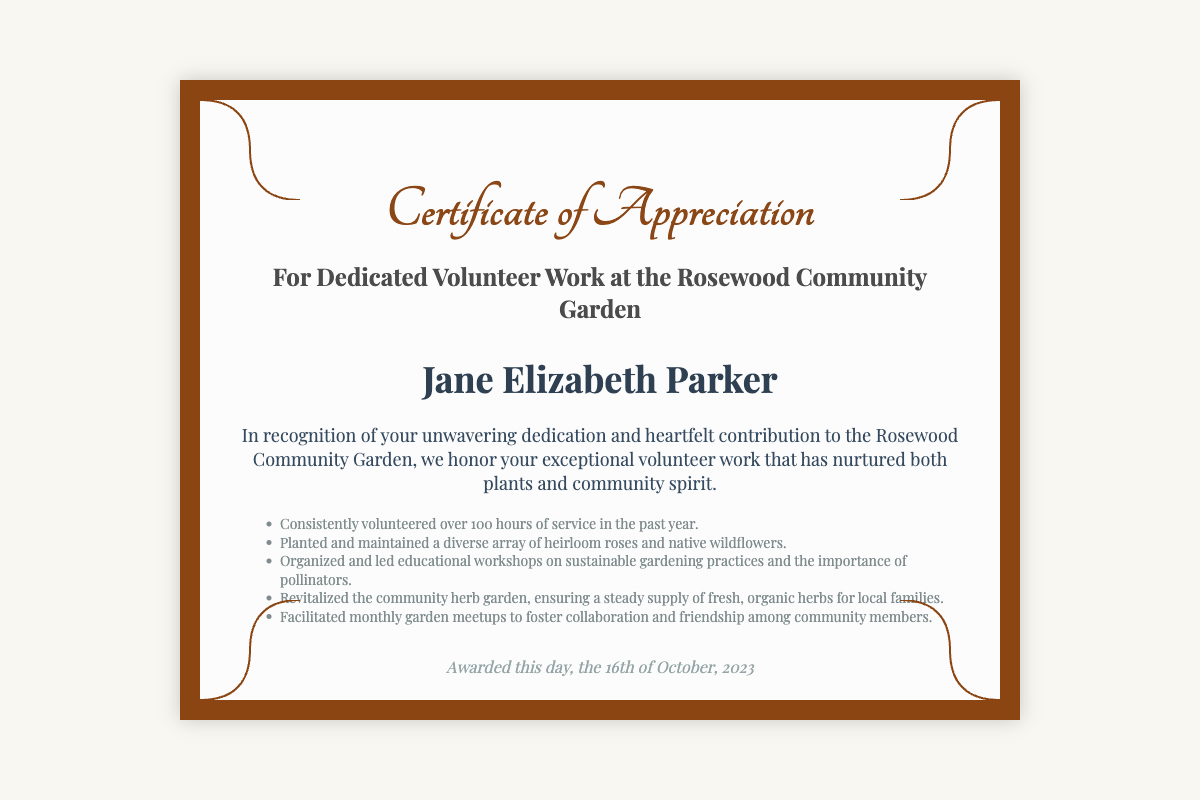What is the name of the recipient? The recipient's name is displayed prominently in the document.
Answer: Jane Elizabeth Parker What organization issued the certificate? The organization is mentioned in the title and signatures section of the document.
Answer: Rosewood Community Garden Association How many hours of service did the recipient volunteer? The document states a specific number of hours the recipient volunteered.
Answer: 100 hours What date was the certificate awarded? The date the certificate was awarded is noted in the footnote section.
Answer: 16th of October, 2023 Who is the President of the Rosewood Community Garden Association? The signature section provides the name of the president.
Answer: Margaret Anne Hughes What type of garden is referenced in the certificate? The document specifies the type of garden associated with the award.
Answer: Community Garden What is one of the achievements mentioned? The achievements section lists several contributions made by the recipient, highlighting their impact.
Answer: Planted and maintained heirloom roses How many signatures are on the certificate? The signatures section of the document shows the number of people who signed it.
Answer: Two What was one initiative organized by the recipient? The recipient's efforts are highlighted in the achievements section, including their initiatives.
Answer: Educational workshops on sustainable gardening practices 